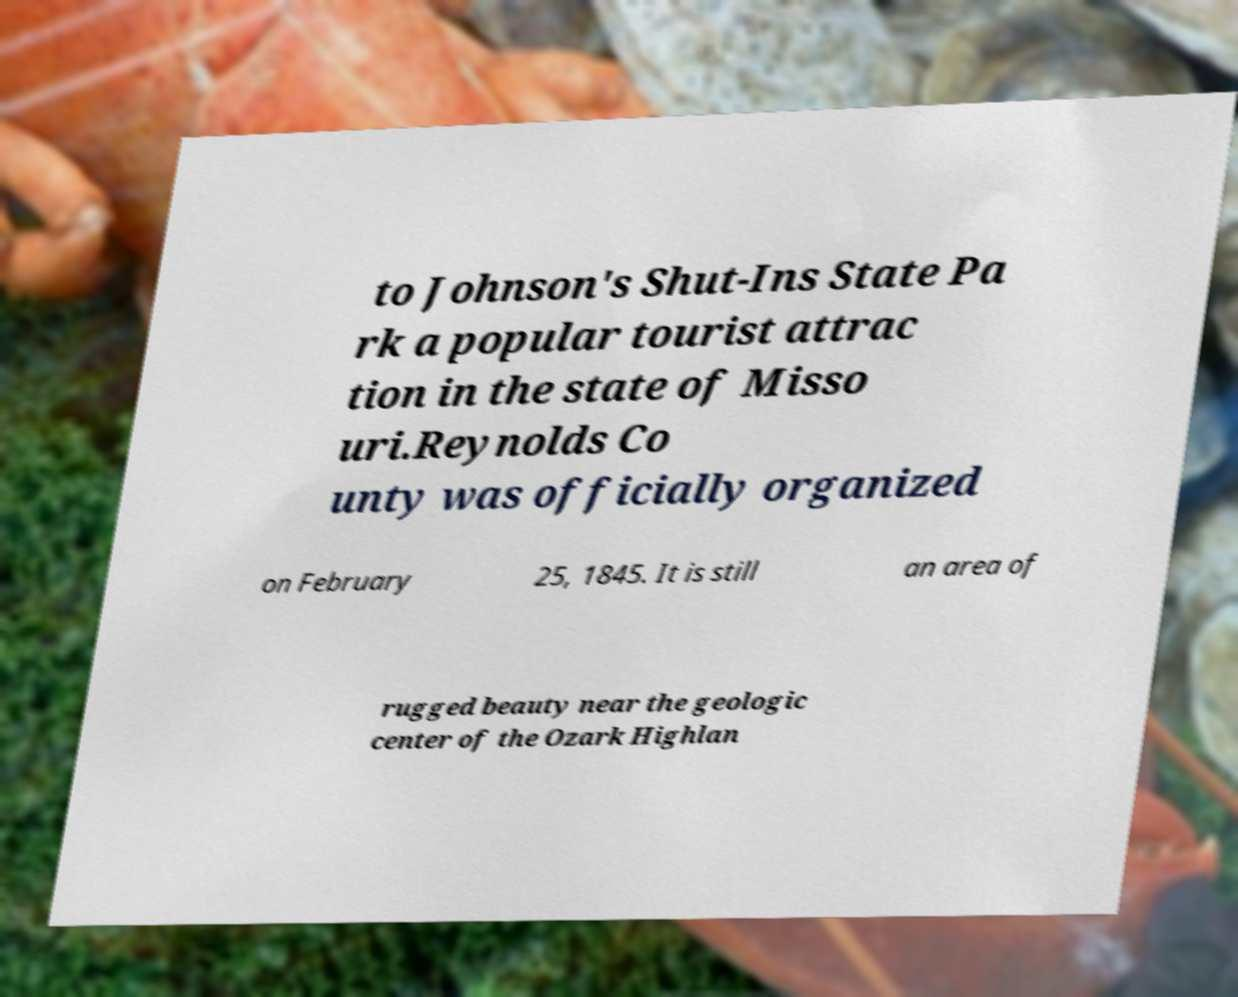What messages or text are displayed in this image? I need them in a readable, typed format. to Johnson's Shut-Ins State Pa rk a popular tourist attrac tion in the state of Misso uri.Reynolds Co unty was officially organized on February 25, 1845. It is still an area of rugged beauty near the geologic center of the Ozark Highlan 